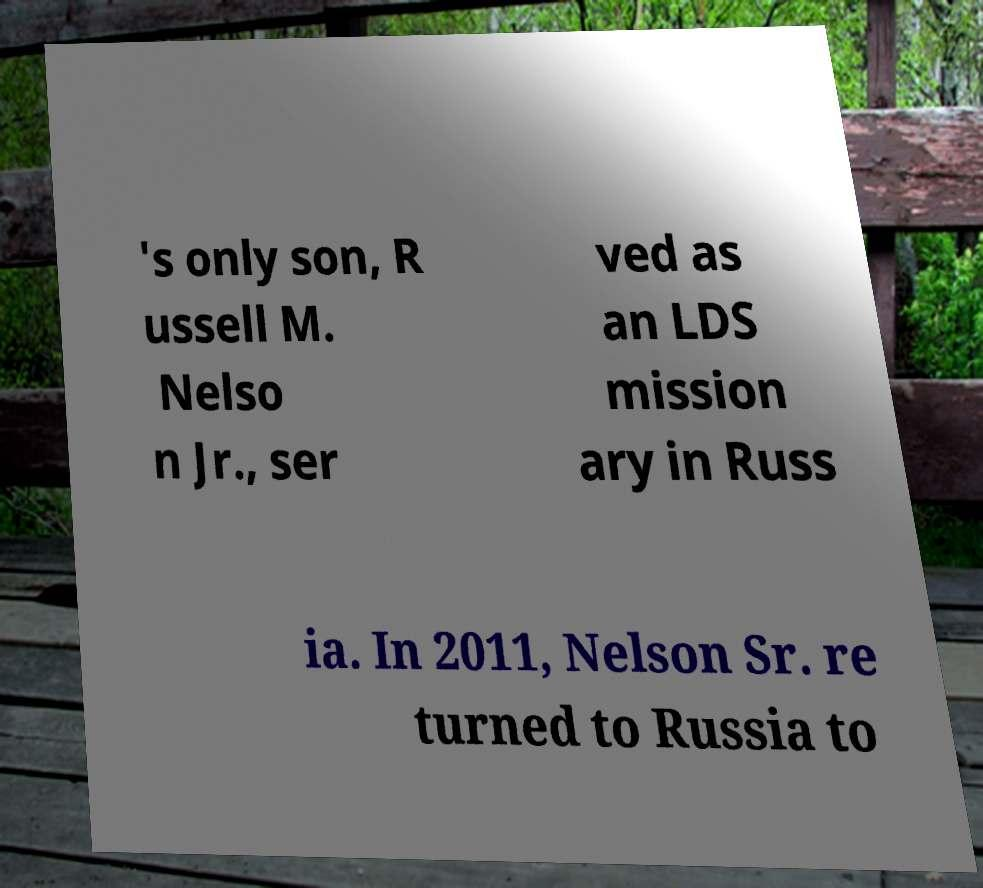There's text embedded in this image that I need extracted. Can you transcribe it verbatim? 's only son, R ussell M. Nelso n Jr., ser ved as an LDS mission ary in Russ ia. In 2011, Nelson Sr. re turned to Russia to 